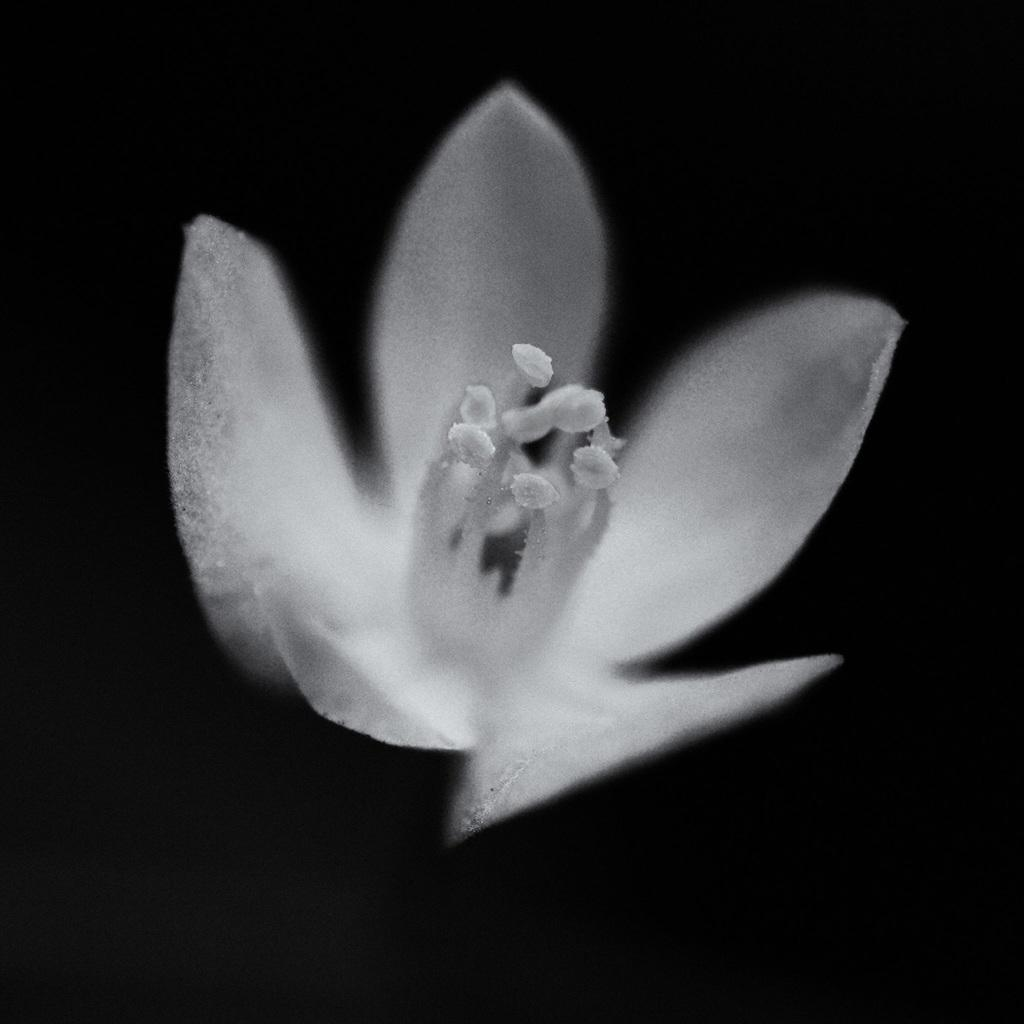What type of flower is in the image? There is a white color flower in the image. What color is the background of the image? The background of the image is black in color. Can you see a mountain in the background of the image? There is no mountain visible in the image; the background is black. What type of creature is interacting with the flower in the image? There is no creature present in the image; it only features a white color flower and a black background. 